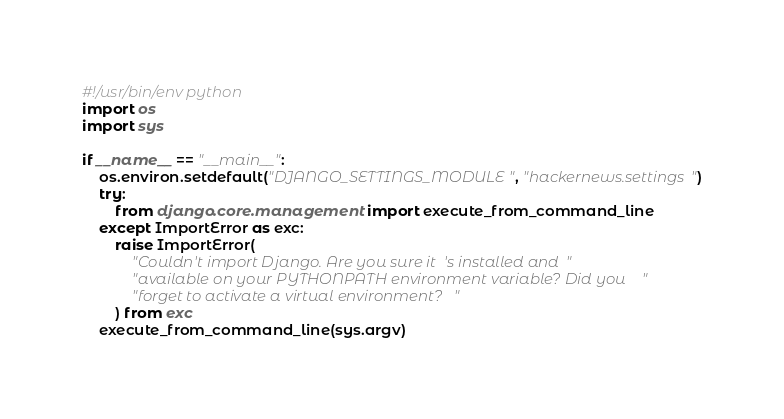<code> <loc_0><loc_0><loc_500><loc_500><_Python_>#!/usr/bin/env python
import os
import sys

if __name__ == "__main__":
    os.environ.setdefault("DJANGO_SETTINGS_MODULE", "hackernews.settings")
    try:
        from django.core.management import execute_from_command_line
    except ImportError as exc:
        raise ImportError(
            "Couldn't import Django. Are you sure it's installed and "
            "available on your PYTHONPATH environment variable? Did you "
            "forget to activate a virtual environment?"
        ) from exc
    execute_from_command_line(sys.argv)
</code> 